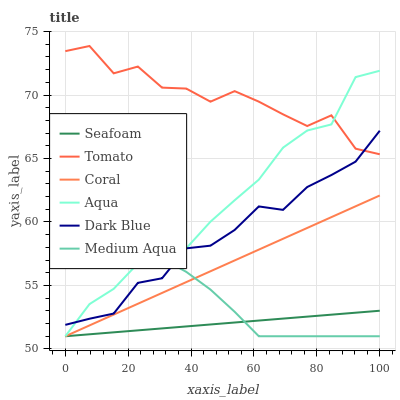Does Seafoam have the minimum area under the curve?
Answer yes or no. Yes. Does Tomato have the maximum area under the curve?
Answer yes or no. Yes. Does Coral have the minimum area under the curve?
Answer yes or no. No. Does Coral have the maximum area under the curve?
Answer yes or no. No. Is Coral the smoothest?
Answer yes or no. Yes. Is Tomato the roughest?
Answer yes or no. Yes. Is Aqua the smoothest?
Answer yes or no. No. Is Aqua the roughest?
Answer yes or no. No. Does Dark Blue have the lowest value?
Answer yes or no. No. Does Tomato have the highest value?
Answer yes or no. Yes. Does Coral have the highest value?
Answer yes or no. No. Is Medium Aqua less than Tomato?
Answer yes or no. Yes. Is Dark Blue greater than Seafoam?
Answer yes or no. Yes. Does Aqua intersect Medium Aqua?
Answer yes or no. Yes. Is Aqua less than Medium Aqua?
Answer yes or no. No. Is Aqua greater than Medium Aqua?
Answer yes or no. No. Does Medium Aqua intersect Tomato?
Answer yes or no. No. 